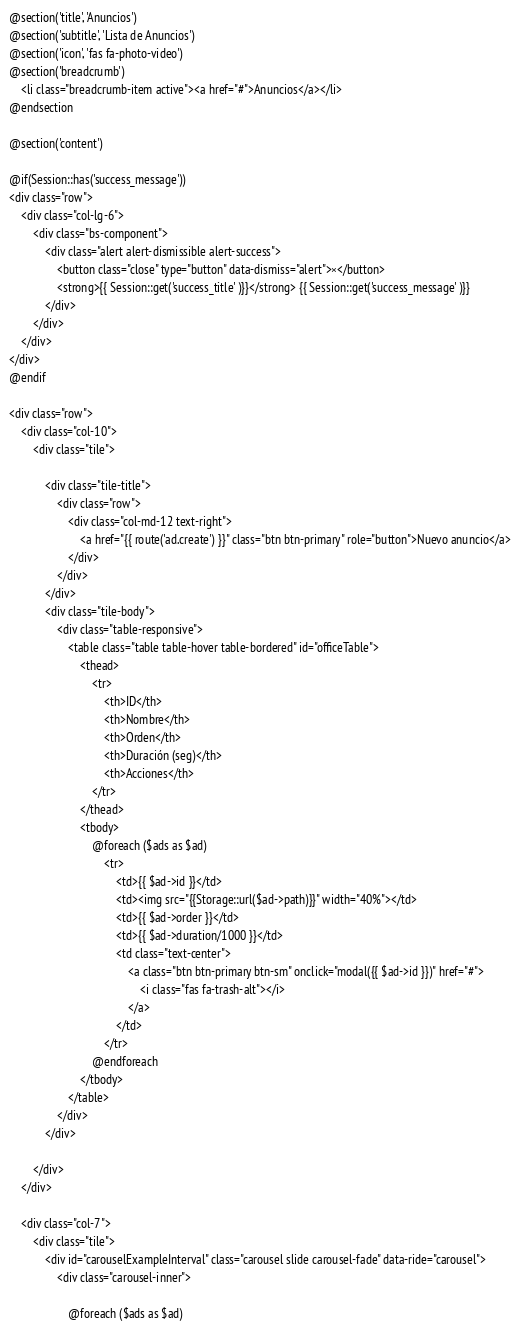<code> <loc_0><loc_0><loc_500><loc_500><_PHP_>@section('title', 'Anuncios')
@section('subtitle', 'Lista de Anuncios')
@section('icon', 'fas fa-photo-video')
@section('breadcrumb')
    <li class="breadcrumb-item active"><a href="#">Anuncios</a></li>
@endsection
    
@section('content')

@if(Session::has('success_message'))
<div class="row">
    <div class="col-lg-6">
        <div class="bs-component">
            <div class="alert alert-dismissible alert-success">
                <button class="close" type="button" data-dismiss="alert">×</button>
                <strong>{{ Session::get('success_title' )}}</strong> {{ Session::get('success_message' )}}
            </div>
        </div>
    </div>
</div>
@endif

<div class="row">
    <div class="col-10">
        <div class="tile">

            <div class="tile-title">
                <div class="row">
                    <div class="col-md-12 text-right">
                        <a href="{{ route('ad.create') }}" class="btn btn-primary" role="button">Nuevo anuncio</a>
                    </div>
                </div>
            </div>
            <div class="tile-body">
                <div class="table-responsive">
                    <table class="table table-hover table-bordered" id="officeTable">
                        <thead>
                            <tr>
                                <th>ID</th>
                                <th>Nombre</th>
                                <th>Orden</th>
                                <th>Duración (seg)</th>
                                <th>Acciones</th>
                            </tr>
                        </thead>
                        <tbody>
                            @foreach ($ads as $ad)
                                <tr>
                                    <td>{{ $ad->id }}</td>
                                    <td><img src="{{Storage::url($ad->path)}}" width="40%"></td>
                                    <td>{{ $ad->order }}</td>
                                    <td>{{ $ad->duration/1000 }}</td>
                                    <td class="text-center">
                                        <a class="btn btn-primary btn-sm" onclick="modal({{ $ad->id }})" href="#">
                                            <i class="fas fa-trash-alt"></i>
                                        </a>
                                    </td>
                                </tr>
                            @endforeach
                        </tbody>
                    </table>
                </div>
            </div>

        </div>
    </div>

    <div class="col-7">
        <div class="tile">
            <div id="carouselExampleInterval" class="carousel slide carousel-fade" data-ride="carousel">
                <div class="carousel-inner">
            
                    @foreach ($ads as $ad)</code> 